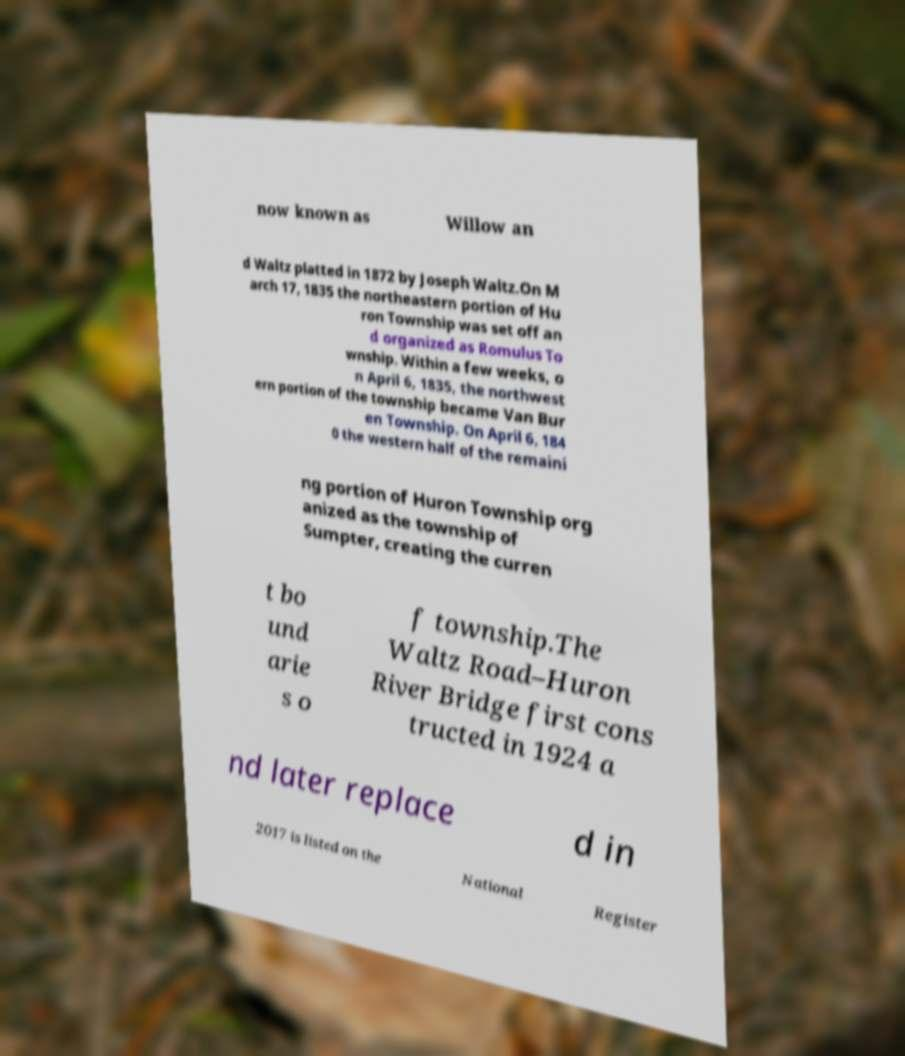Could you extract and type out the text from this image? now known as Willow an d Waltz platted in 1872 by Joseph Waltz.On M arch 17, 1835 the northeastern portion of Hu ron Township was set off an d organized as Romulus To wnship. Within a few weeks, o n April 6, 1835, the northwest ern portion of the township became Van Bur en Township. On April 6, 184 0 the western half of the remaini ng portion of Huron Township org anized as the township of Sumpter, creating the curren t bo und arie s o f township.The Waltz Road–Huron River Bridge first cons tructed in 1924 a nd later replace d in 2017 is listed on the National Register 